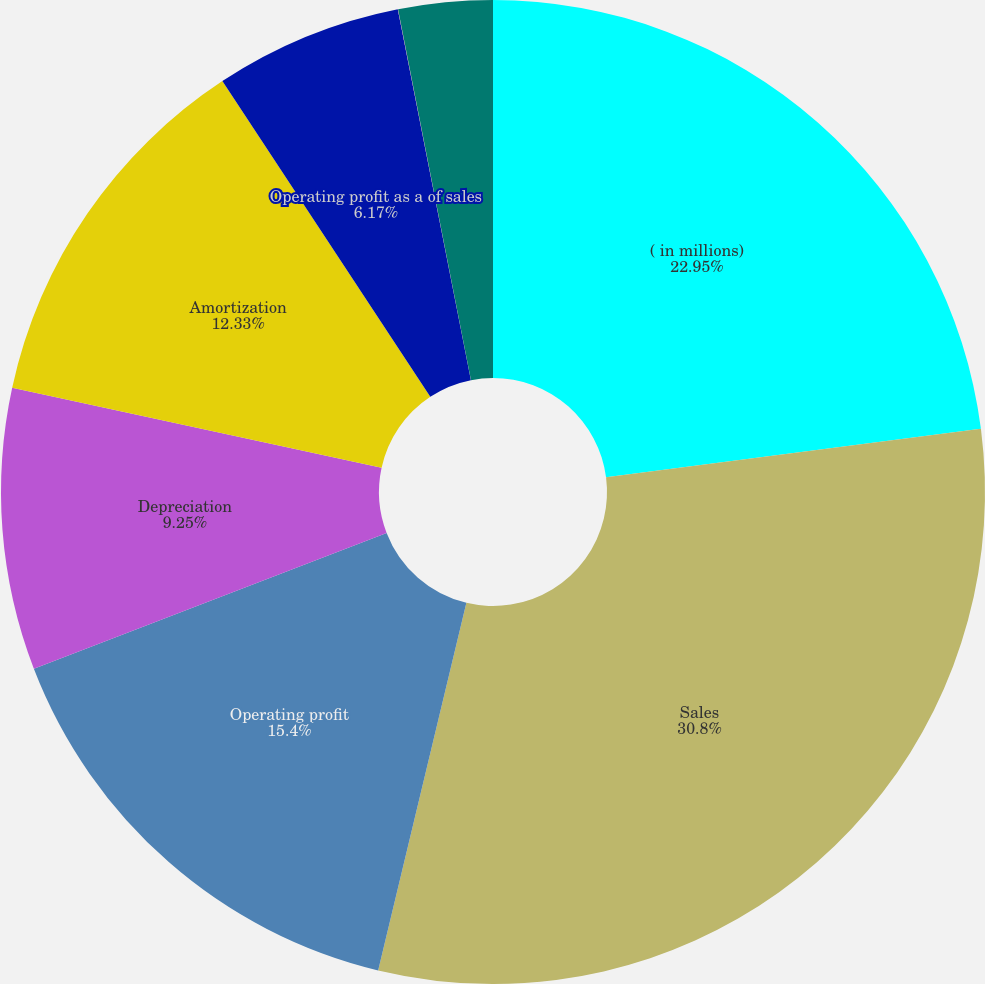<chart> <loc_0><loc_0><loc_500><loc_500><pie_chart><fcel>( in millions)<fcel>Sales<fcel>Operating profit<fcel>Depreciation<fcel>Amortization<fcel>Operating profit as a of sales<fcel>Depreciation as a of sales<fcel>Amortization as a of sales<nl><fcel>22.95%<fcel>30.8%<fcel>15.4%<fcel>9.25%<fcel>12.33%<fcel>6.17%<fcel>0.01%<fcel>3.09%<nl></chart> 